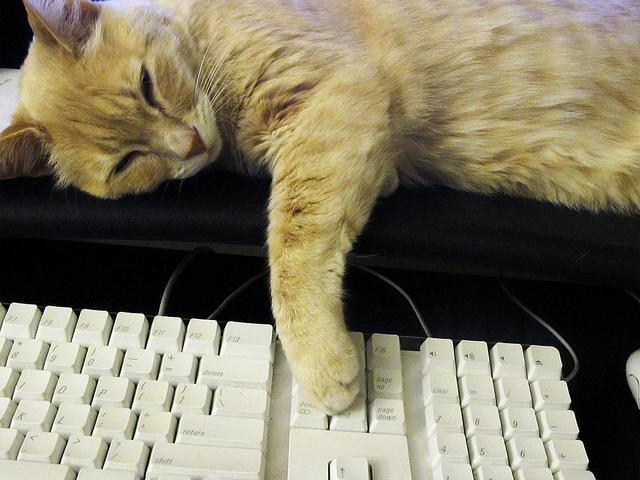What part of the keyboard is the cat using?
Short answer required. Middle. Is this cat typing anything to it's owner?
Give a very brief answer. No. Is the cat lying down?
Answer briefly. Yes. Is the cat typing?
Quick response, please. No. 